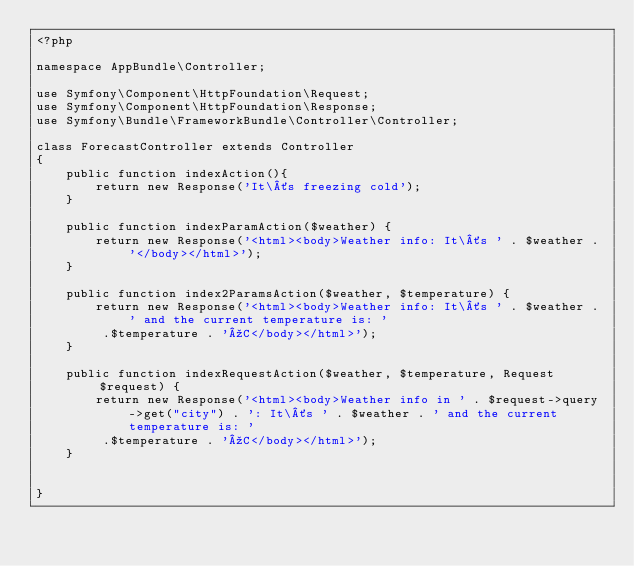<code> <loc_0><loc_0><loc_500><loc_500><_PHP_><?php

namespace AppBundle\Controller;

use Symfony\Component\HttpFoundation\Request;
use Symfony\Component\HttpFoundation\Response;
use Symfony\Bundle\FrameworkBundle\Controller\Controller;

class ForecastController extends Controller
{
    public function indexAction(){
        return new Response('It\´s freezing cold');
    }

    public function indexParamAction($weather) {
        return new Response('<html><body>Weather info: It\´s ' . $weather . '</body></html>');
    }

    public function index2ParamsAction($weather, $temperature) {
        return new Response('<html><body>Weather info: It\´s ' . $weather . ' and the current temperature is: '
         .$temperature . 'ºC</body></html>');
    }

    public function indexRequestAction($weather, $temperature, Request $request) {
        return new Response('<html><body>Weather info in ' . $request->query->get("city") . ': It\´s ' . $weather . ' and the current temperature is: '
         .$temperature . 'ºC</body></html>');
    }


}
</code> 